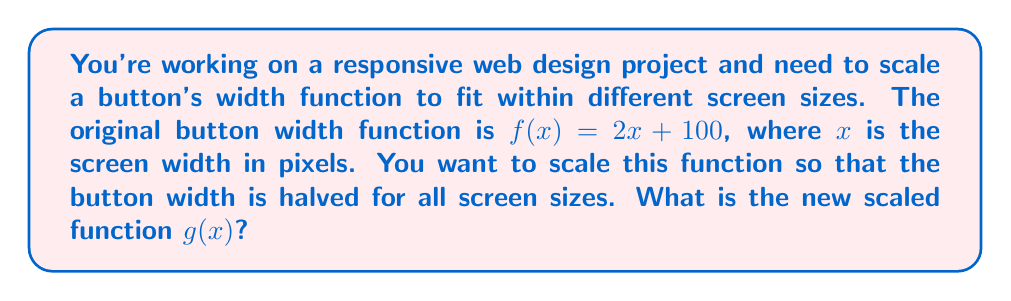What is the answer to this math problem? To scale the function $f(x) = 2x + 100$ so that the button width is halved for all screen sizes, we need to follow these steps:

1. Identify the original function:
   $f(x) = 2x + 100$

2. To halve the result of the function for all inputs, we need to multiply the entire function by $\frac{1}{2}$:
   $g(x) = \frac{1}{2} \cdot f(x)$

3. Distribute the $\frac{1}{2}$ to all terms in the function:
   $g(x) = \frac{1}{2} \cdot (2x + 100)$
   $g(x) = (\frac{1}{2} \cdot 2x) + (\frac{1}{2} \cdot 100)$

4. Simplify:
   $g(x) = x + 50$

Therefore, the new scaled function $g(x)$ that halves the button width for all screen sizes is $g(x) = x + 50$.
Answer: $g(x) = x + 50$ 